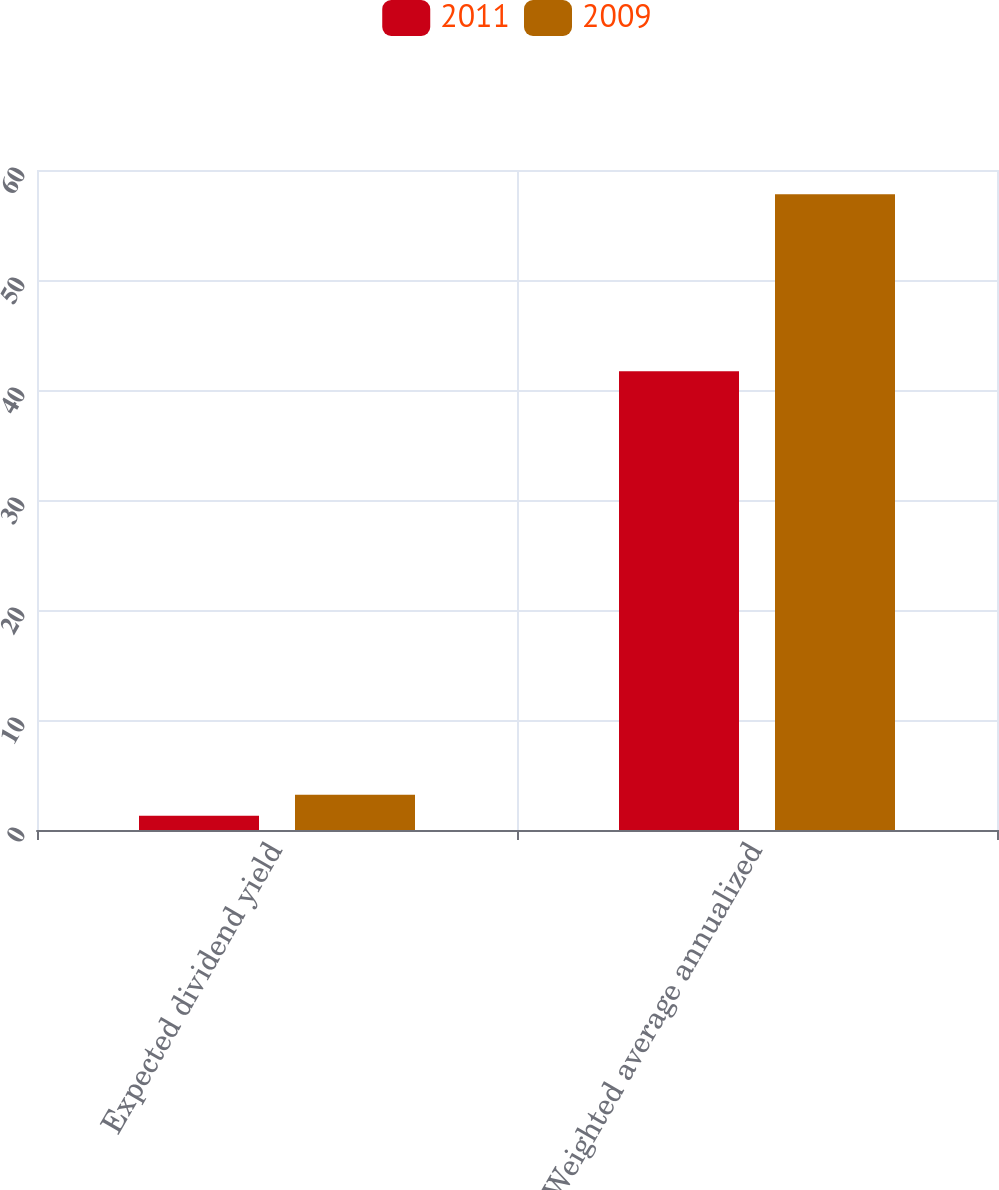Convert chart. <chart><loc_0><loc_0><loc_500><loc_500><stacked_bar_chart><ecel><fcel>Expected dividend yield<fcel>Weighted average annualized<nl><fcel>2011<fcel>1.3<fcel>41.7<nl><fcel>2009<fcel>3.2<fcel>57.8<nl></chart> 